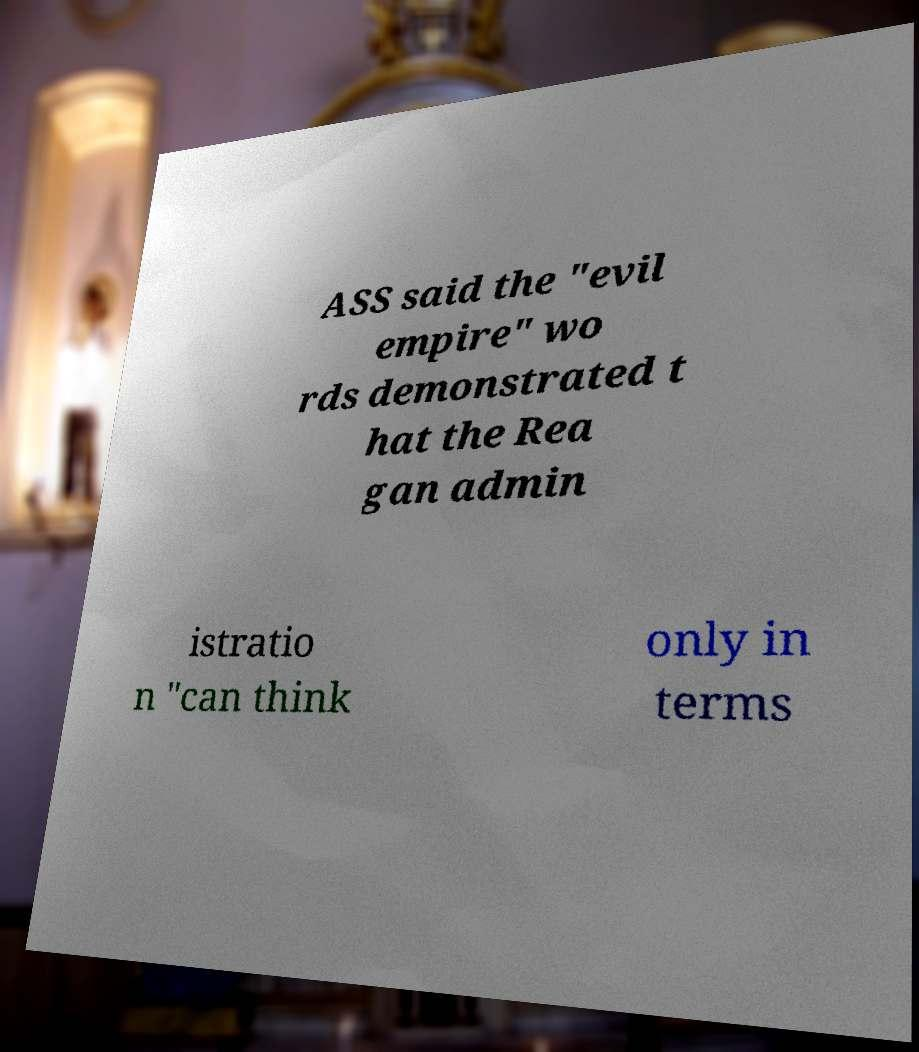What messages or text are displayed in this image? I need them in a readable, typed format. ASS said the "evil empire" wo rds demonstrated t hat the Rea gan admin istratio n "can think only in terms 